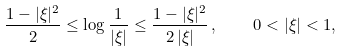Convert formula to latex. <formula><loc_0><loc_0><loc_500><loc_500>\frac { 1 - | \xi | ^ { 2 } } { 2 } \leq \log \frac { 1 } { | \xi | } \leq \frac { 1 - | \xi | ^ { 2 } } { 2 \, | \xi | } \, , \quad 0 < | \xi | < 1 ,</formula> 